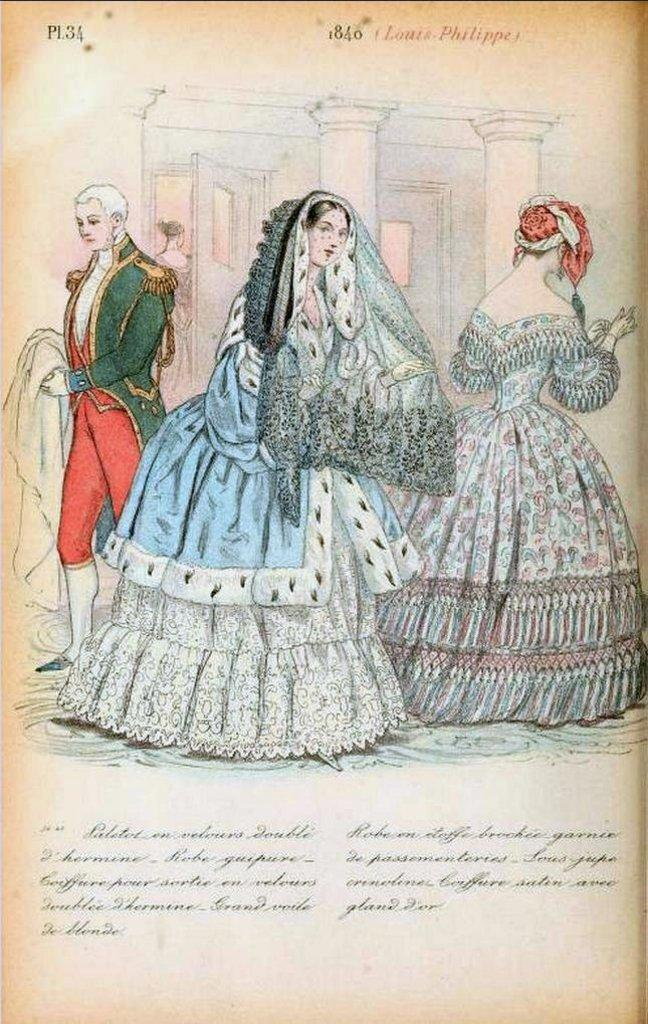What is featured on the poster in the image? There is a poster in the image, and it has text on it. Who or what can be seen in the image besides the poster? There are people and a building visible in the image. Can you tell me how many scarecrows are depicted on the poster? There is no scarecrow present on the poster; it only has text. What type of egg is shown in the image? There is no egg present in the image. 